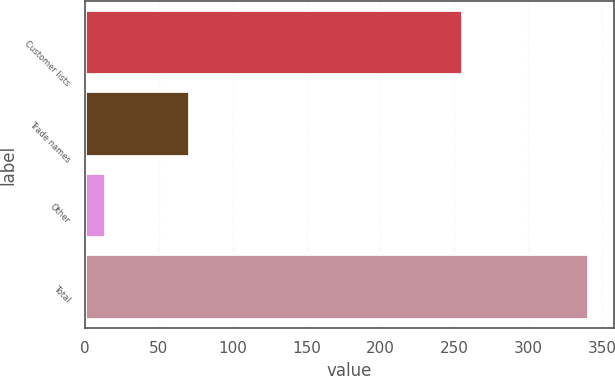<chart> <loc_0><loc_0><loc_500><loc_500><bar_chart><fcel>Customer lists<fcel>Trade names<fcel>Other<fcel>Total<nl><fcel>255.8<fcel>71<fcel>14.1<fcel>340.9<nl></chart> 